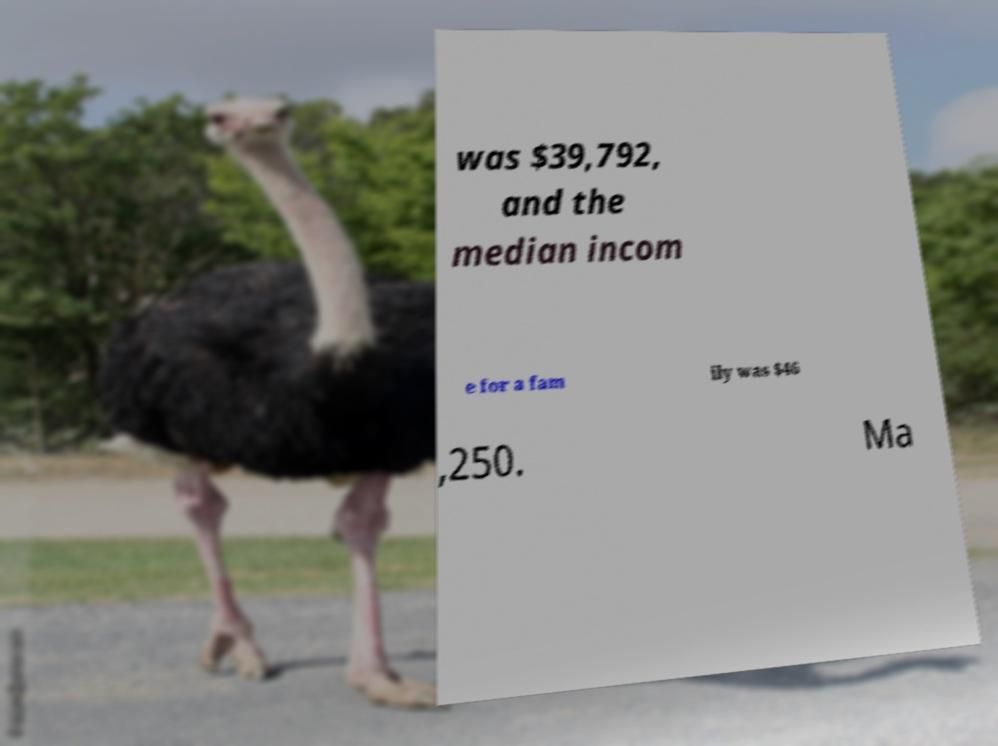For documentation purposes, I need the text within this image transcribed. Could you provide that? was $39,792, and the median incom e for a fam ily was $46 ,250. Ma 